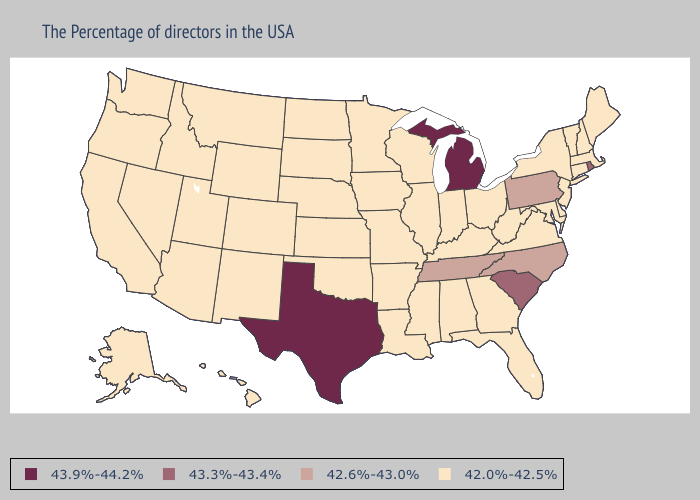Which states have the highest value in the USA?
Give a very brief answer. Michigan, Texas. Does Louisiana have a higher value than North Dakota?
Give a very brief answer. No. What is the lowest value in the West?
Give a very brief answer. 42.0%-42.5%. Name the states that have a value in the range 43.3%-43.4%?
Short answer required. Rhode Island, South Carolina. What is the value of Nevada?
Be succinct. 42.0%-42.5%. Among the states that border Delaware , does Maryland have the highest value?
Keep it brief. No. What is the highest value in the South ?
Keep it brief. 43.9%-44.2%. What is the value of Wyoming?
Concise answer only. 42.0%-42.5%. What is the value of New Jersey?
Answer briefly. 42.0%-42.5%. Name the states that have a value in the range 43.9%-44.2%?
Quick response, please. Michigan, Texas. What is the lowest value in states that border Utah?
Answer briefly. 42.0%-42.5%. Does Maine have the lowest value in the USA?
Write a very short answer. Yes. What is the highest value in the USA?
Quick response, please. 43.9%-44.2%. Among the states that border Virginia , does Kentucky have the lowest value?
Keep it brief. Yes. 